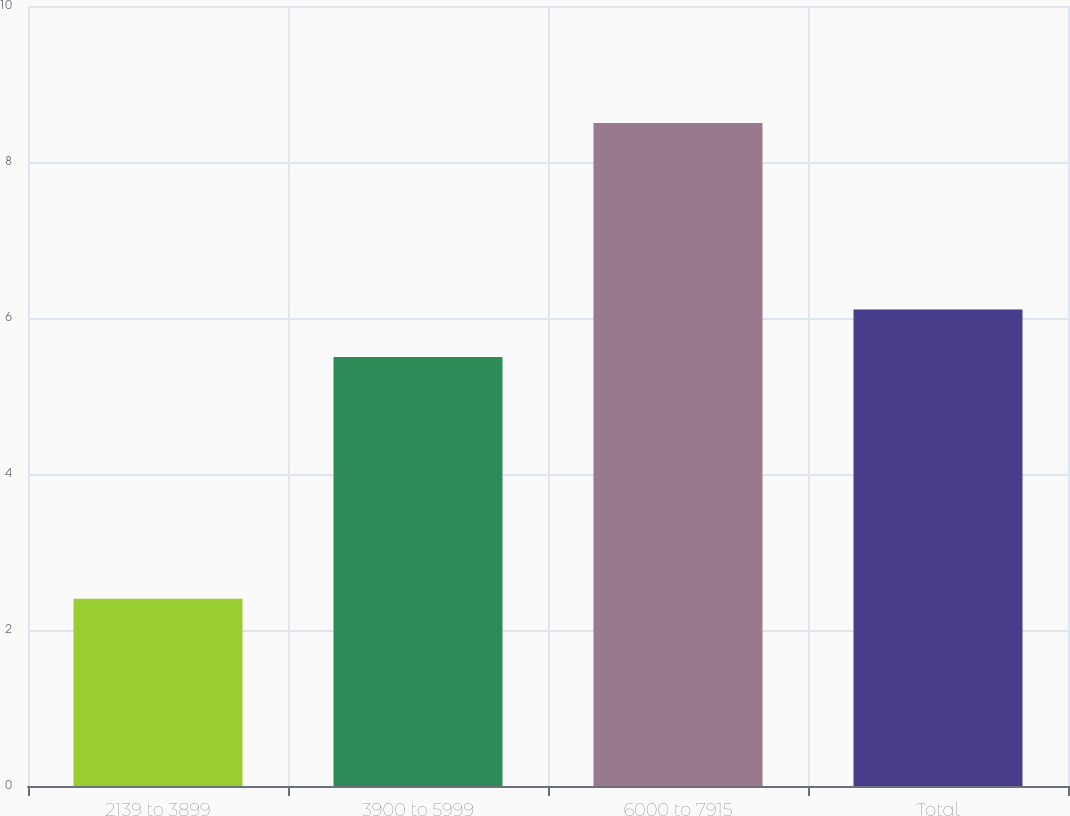Convert chart. <chart><loc_0><loc_0><loc_500><loc_500><bar_chart><fcel>2139 to 3899<fcel>3900 to 5999<fcel>6000 to 7915<fcel>Total<nl><fcel>2.4<fcel>5.5<fcel>8.5<fcel>6.11<nl></chart> 